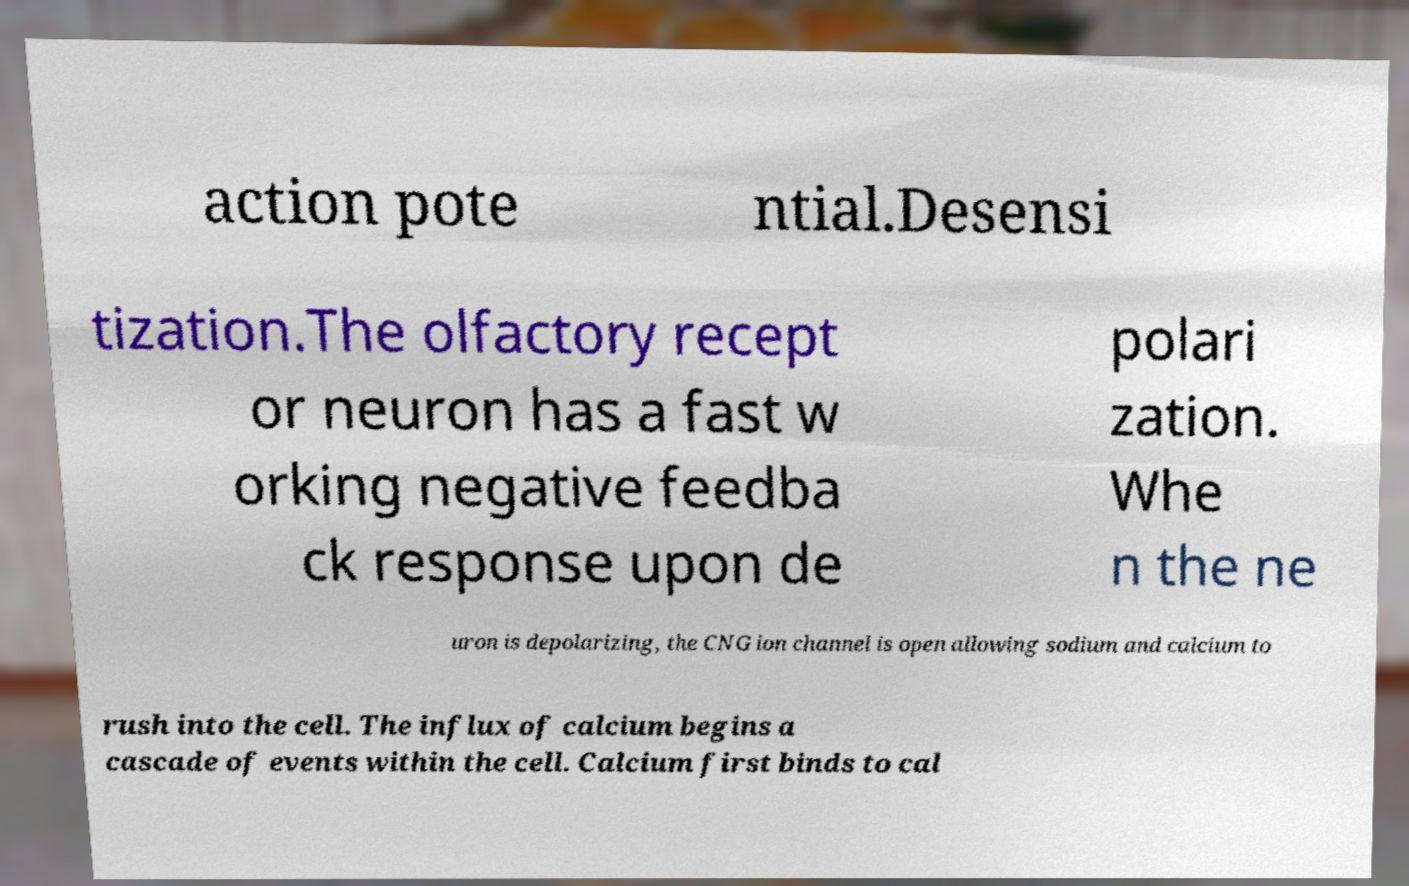Can you read and provide the text displayed in the image?This photo seems to have some interesting text. Can you extract and type it out for me? action pote ntial.Desensi tization.The olfactory recept or neuron has a fast w orking negative feedba ck response upon de polari zation. Whe n the ne uron is depolarizing, the CNG ion channel is open allowing sodium and calcium to rush into the cell. The influx of calcium begins a cascade of events within the cell. Calcium first binds to cal 